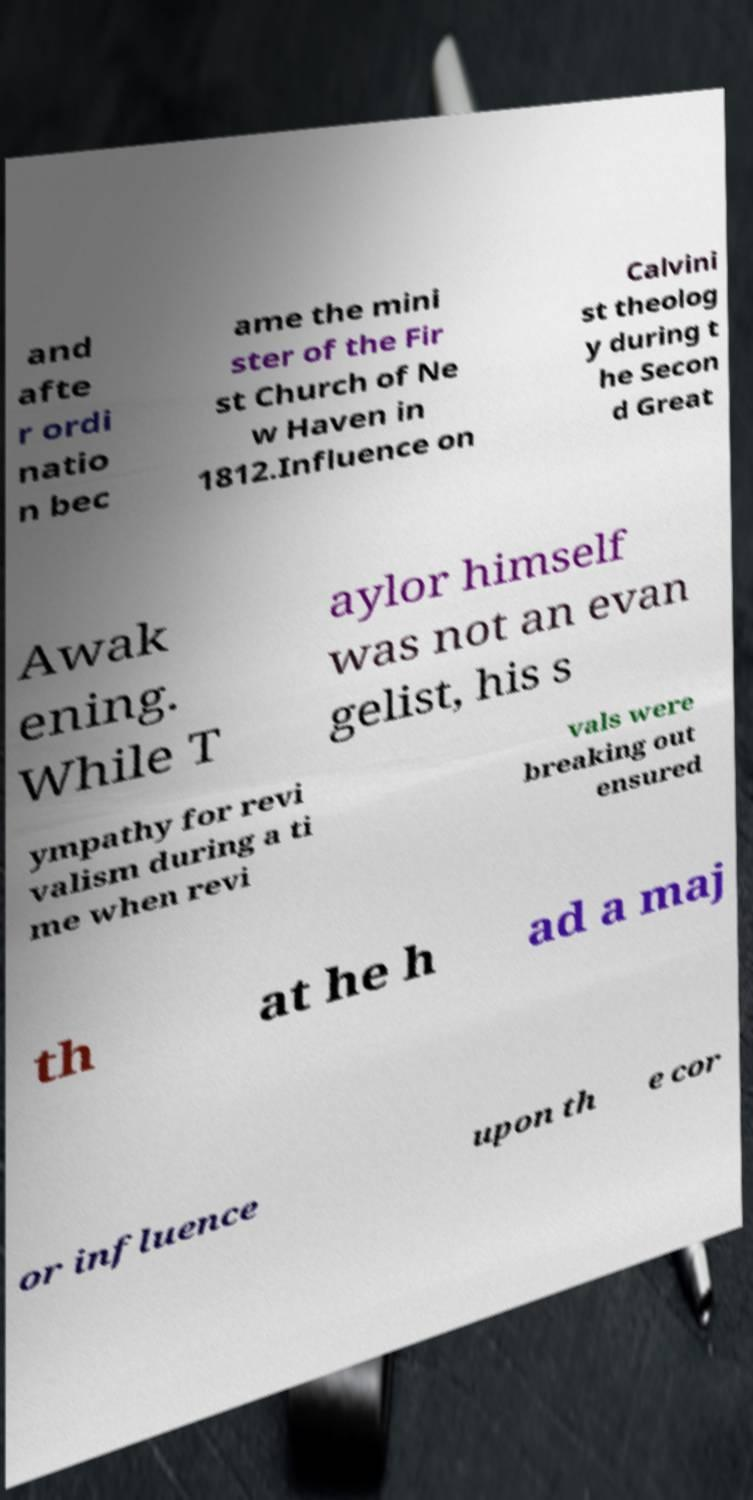What messages or text are displayed in this image? I need them in a readable, typed format. and afte r ordi natio n bec ame the mini ster of the Fir st Church of Ne w Haven in 1812.Influence on Calvini st theolog y during t he Secon d Great Awak ening. While T aylor himself was not an evan gelist, his s ympathy for revi valism during a ti me when revi vals were breaking out ensured th at he h ad a maj or influence upon th e cor 